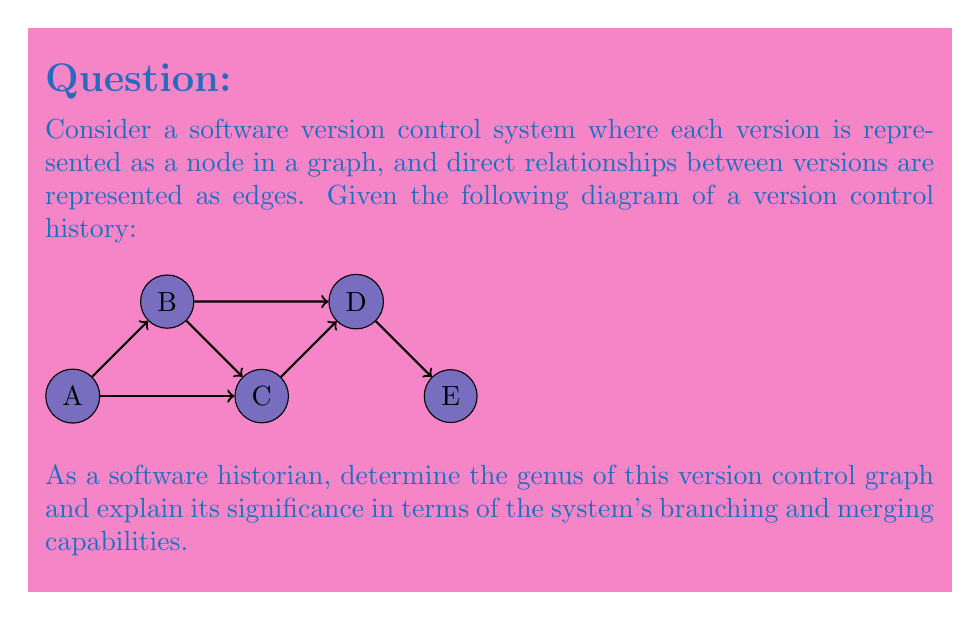Show me your answer to this math problem. To determine the genus of the version control graph, we need to follow these steps:

1. Identify the graph's properties:
   - The graph is planar, meaning it can be drawn on a plane without edge crossings.
   - It has 5 vertices (A, B, C, D, E) and 7 edges.

2. Calculate the number of faces:
   - Use Euler's formula for planar graphs: $V - E + F = 2$
   - Where $V$ is the number of vertices, $E$ is the number of edges, and $F$ is the number of faces.
   - Substituting known values: $5 - 7 + F = 2$
   - Solving for $F$: $F = 4$

3. Determine the genus:
   - For a planar graph, the genus is 0.
   - The genus represents the number of "holes" or "handles" needed to embed the graph on a surface without crossings.

4. Interpret the result:
   - A genus of 0 indicates that the version control system can be fully represented on a plane.
   - This means that all branching and merging operations can be visualized and managed in a two-dimensional space.
   - The system supports linear progression (main branch) as well as parallel development (side branches) and merging (converging edges).

5. Significance for version control:
   - The planar nature (genus 0) allows for easy visualization and management of the version history.
   - It supports common version control operations like branching, merging, and linear progression without topological constraints.
   - The system can handle complex development workflows while maintaining a comprehensible structure.
Answer: Genus 0 (planar graph) 